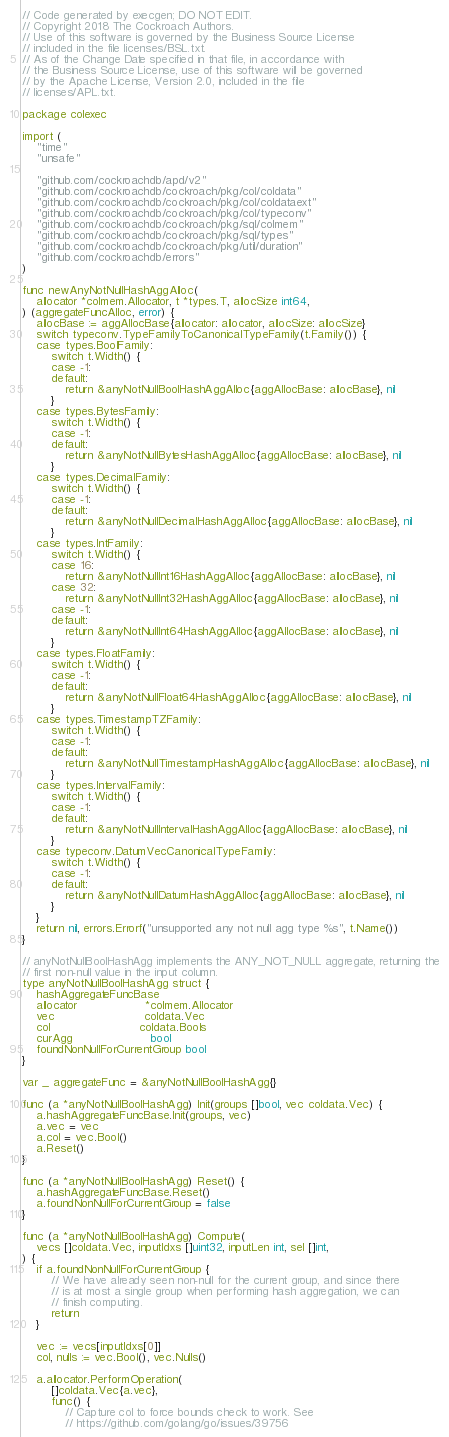<code> <loc_0><loc_0><loc_500><loc_500><_Go_>// Code generated by execgen; DO NOT EDIT.
// Copyright 2018 The Cockroach Authors.
// Use of this software is governed by the Business Source License
// included in the file licenses/BSL.txt.
// As of the Change Date specified in that file, in accordance with
// the Business Source License, use of this software will be governed
// by the Apache License, Version 2.0, included in the file
// licenses/APL.txt.

package colexec

import (
	"time"
	"unsafe"

	"github.com/cockroachdb/apd/v2"
	"github.com/cockroachdb/cockroach/pkg/col/coldata"
	"github.com/cockroachdb/cockroach/pkg/col/coldataext"
	"github.com/cockroachdb/cockroach/pkg/col/typeconv"
	"github.com/cockroachdb/cockroach/pkg/sql/colmem"
	"github.com/cockroachdb/cockroach/pkg/sql/types"
	"github.com/cockroachdb/cockroach/pkg/util/duration"
	"github.com/cockroachdb/errors"
)

func newAnyNotNullHashAggAlloc(
	allocator *colmem.Allocator, t *types.T, allocSize int64,
) (aggregateFuncAlloc, error) {
	allocBase := aggAllocBase{allocator: allocator, allocSize: allocSize}
	switch typeconv.TypeFamilyToCanonicalTypeFamily(t.Family()) {
	case types.BoolFamily:
		switch t.Width() {
		case -1:
		default:
			return &anyNotNullBoolHashAggAlloc{aggAllocBase: allocBase}, nil
		}
	case types.BytesFamily:
		switch t.Width() {
		case -1:
		default:
			return &anyNotNullBytesHashAggAlloc{aggAllocBase: allocBase}, nil
		}
	case types.DecimalFamily:
		switch t.Width() {
		case -1:
		default:
			return &anyNotNullDecimalHashAggAlloc{aggAllocBase: allocBase}, nil
		}
	case types.IntFamily:
		switch t.Width() {
		case 16:
			return &anyNotNullInt16HashAggAlloc{aggAllocBase: allocBase}, nil
		case 32:
			return &anyNotNullInt32HashAggAlloc{aggAllocBase: allocBase}, nil
		case -1:
		default:
			return &anyNotNullInt64HashAggAlloc{aggAllocBase: allocBase}, nil
		}
	case types.FloatFamily:
		switch t.Width() {
		case -1:
		default:
			return &anyNotNullFloat64HashAggAlloc{aggAllocBase: allocBase}, nil
		}
	case types.TimestampTZFamily:
		switch t.Width() {
		case -1:
		default:
			return &anyNotNullTimestampHashAggAlloc{aggAllocBase: allocBase}, nil
		}
	case types.IntervalFamily:
		switch t.Width() {
		case -1:
		default:
			return &anyNotNullIntervalHashAggAlloc{aggAllocBase: allocBase}, nil
		}
	case typeconv.DatumVecCanonicalTypeFamily:
		switch t.Width() {
		case -1:
		default:
			return &anyNotNullDatumHashAggAlloc{aggAllocBase: allocBase}, nil
		}
	}
	return nil, errors.Errorf("unsupported any not null agg type %s", t.Name())
}

// anyNotNullBoolHashAgg implements the ANY_NOT_NULL aggregate, returning the
// first non-null value in the input column.
type anyNotNullBoolHashAgg struct {
	hashAggregateFuncBase
	allocator                   *colmem.Allocator
	vec                         coldata.Vec
	col                         coldata.Bools
	curAgg                      bool
	foundNonNullForCurrentGroup bool
}

var _ aggregateFunc = &anyNotNullBoolHashAgg{}

func (a *anyNotNullBoolHashAgg) Init(groups []bool, vec coldata.Vec) {
	a.hashAggregateFuncBase.Init(groups, vec)
	a.vec = vec
	a.col = vec.Bool()
	a.Reset()
}

func (a *anyNotNullBoolHashAgg) Reset() {
	a.hashAggregateFuncBase.Reset()
	a.foundNonNullForCurrentGroup = false
}

func (a *anyNotNullBoolHashAgg) Compute(
	vecs []coldata.Vec, inputIdxs []uint32, inputLen int, sel []int,
) {
	if a.foundNonNullForCurrentGroup {
		// We have already seen non-null for the current group, and since there
		// is at most a single group when performing hash aggregation, we can
		// finish computing.
		return
	}

	vec := vecs[inputIdxs[0]]
	col, nulls := vec.Bool(), vec.Nulls()

	a.allocator.PerformOperation(
		[]coldata.Vec{a.vec},
		func() {
			// Capture col to force bounds check to work. See
			// https://github.com/golang/go/issues/39756</code> 